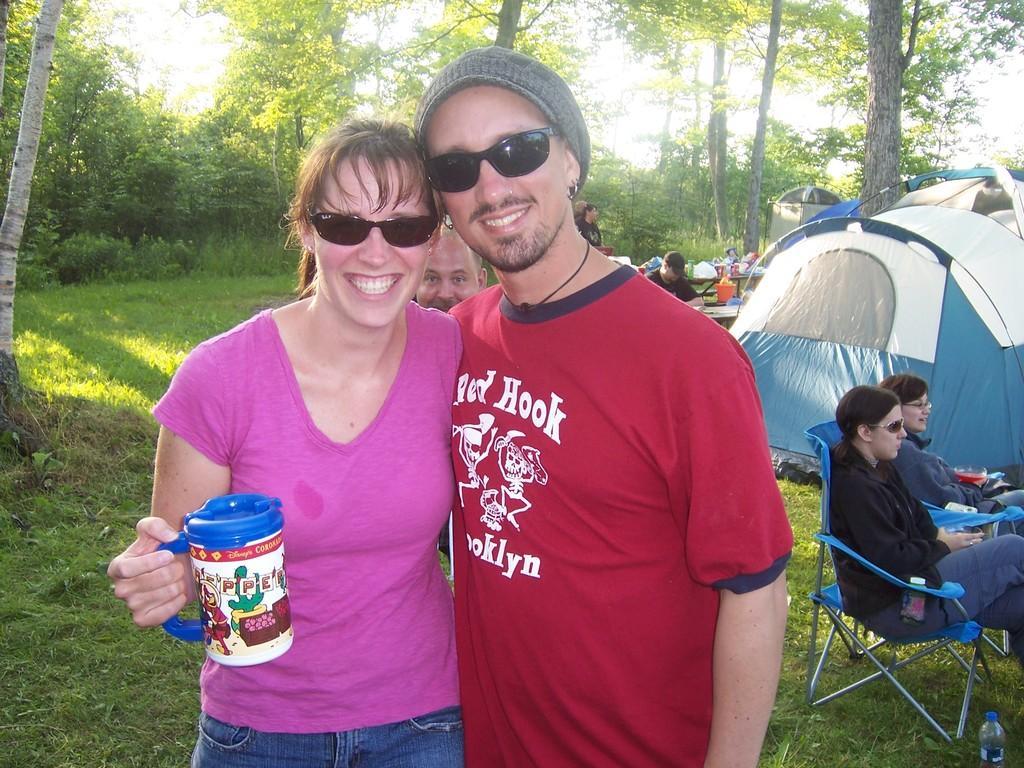Could you give a brief overview of what you see in this image? In this image we can see some people standing. In that a woman is holding a container. We can also see grass, plants, bottle on the ground, the bark of the trees, a tent, some people sitting on the chairs, tables containing some objects on them, a group of trees and the sky. 